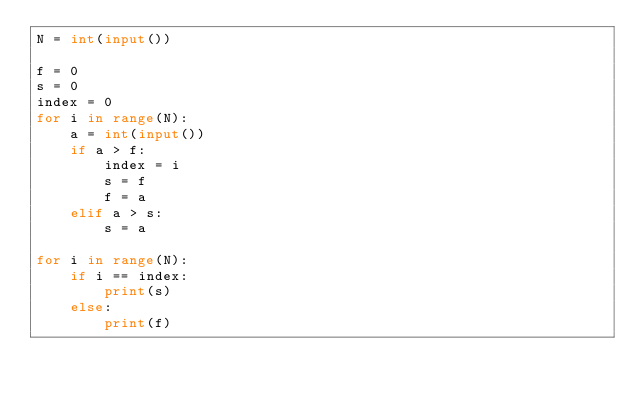<code> <loc_0><loc_0><loc_500><loc_500><_Python_>N = int(input())

f = 0
s = 0
index = 0
for i in range(N):
    a = int(input())
    if a > f:
        index = i
        s = f
        f = a
    elif a > s:
        s = a

for i in range(N):
    if i == index:
        print(s)
    else:
        print(f)</code> 